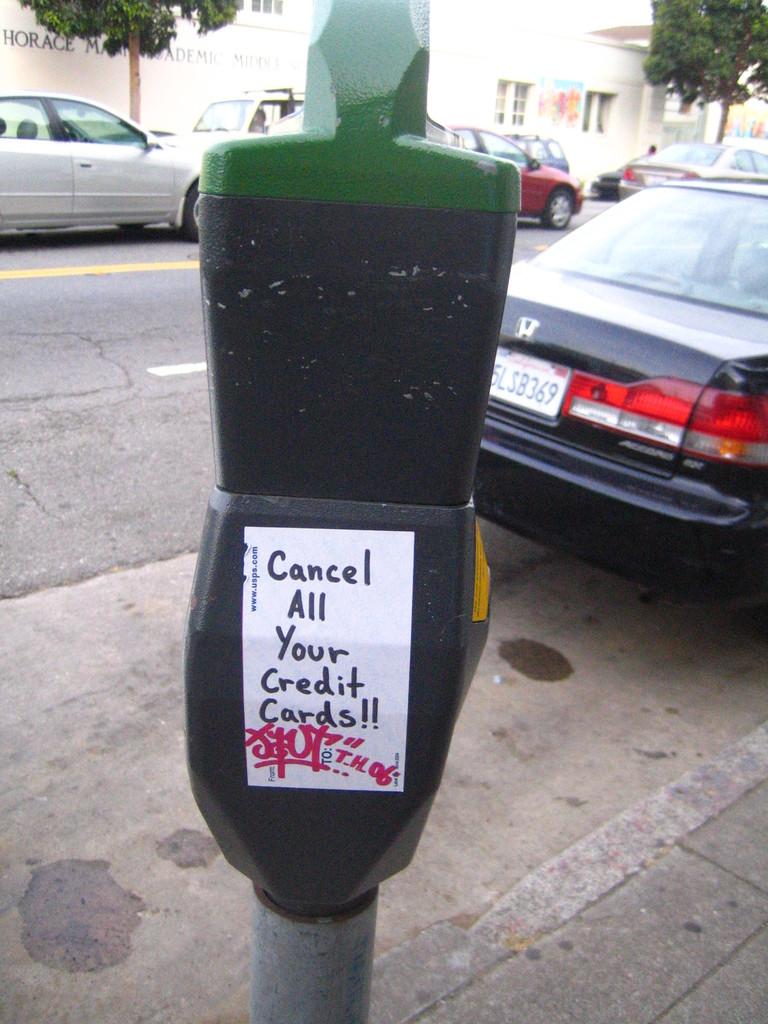How many exclamation points are on the sticker?
Your answer should be compact. 2. 